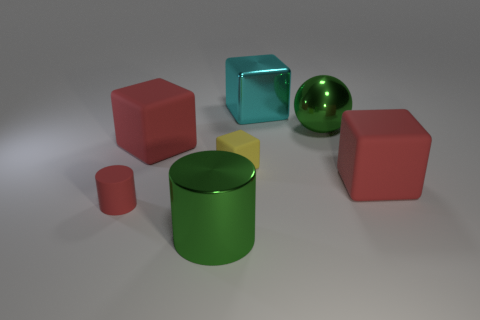Are the red block to the left of the cyan object and the red cylinder made of the same material?
Your response must be concise. Yes. Is the number of big green metal cylinders to the left of the red rubber cylinder less than the number of big brown rubber spheres?
Keep it short and to the point. No. What shape is the tiny matte object that is to the left of the big metallic cylinder?
Ensure brevity in your answer.  Cylinder. What shape is the green thing that is the same size as the green sphere?
Keep it short and to the point. Cylinder. Are there any other things that have the same shape as the tiny red object?
Make the answer very short. Yes. Do the large red matte object to the right of the big cyan metal thing and the large red object behind the tiny yellow block have the same shape?
Offer a terse response. Yes. What is the material of the cube that is the same size as the red rubber cylinder?
Ensure brevity in your answer.  Rubber. How many other objects are there of the same material as the tiny yellow object?
Your answer should be very brief. 3. The big green metal object that is in front of the thing to the right of the big metallic ball is what shape?
Your answer should be compact. Cylinder. What number of things are large green objects or large matte things right of the big cyan shiny thing?
Your answer should be very brief. 3. 